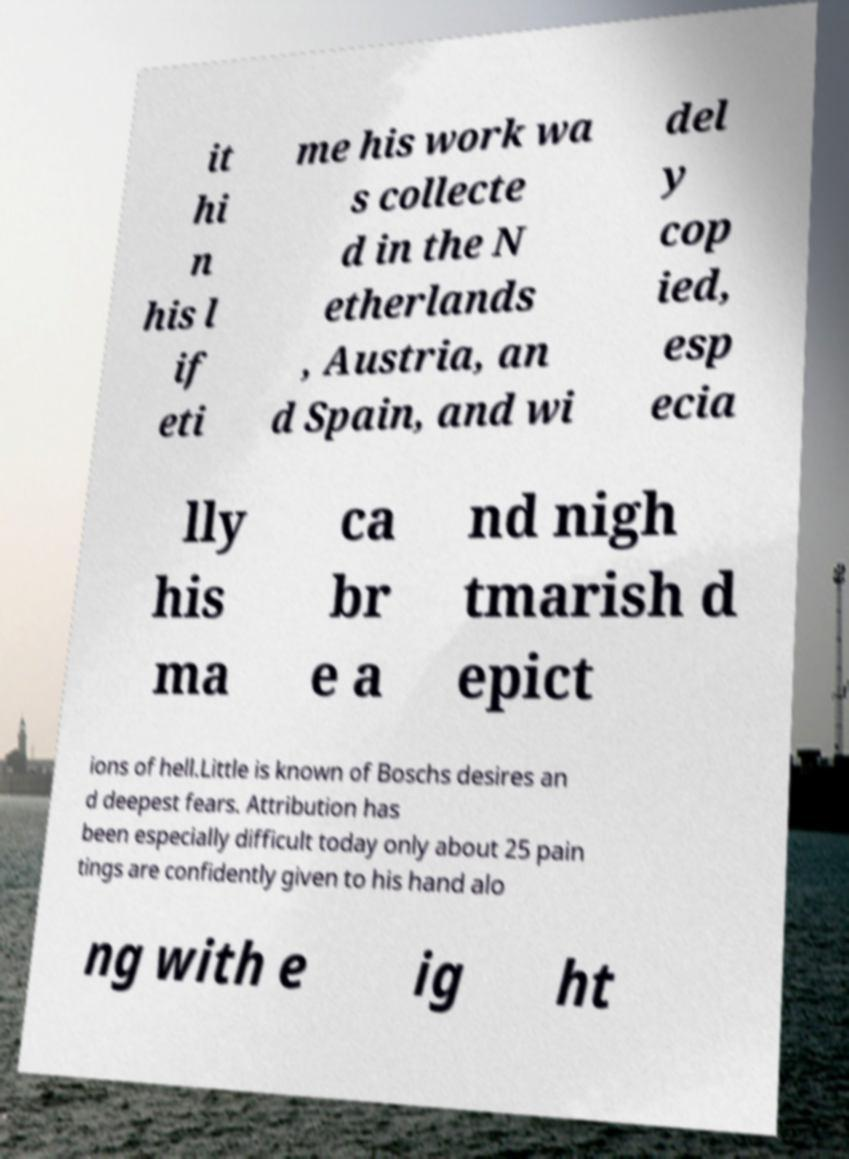Could you extract and type out the text from this image? it hi n his l if eti me his work wa s collecte d in the N etherlands , Austria, an d Spain, and wi del y cop ied, esp ecia lly his ma ca br e a nd nigh tmarish d epict ions of hell.Little is known of Boschs desires an d deepest fears. Attribution has been especially difficult today only about 25 pain tings are confidently given to his hand alo ng with e ig ht 